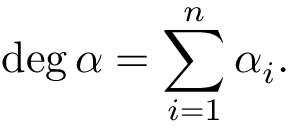<formula> <loc_0><loc_0><loc_500><loc_500>\deg \alpha = \sum _ { i = 1 } ^ { n } \alpha _ { i } .</formula> 